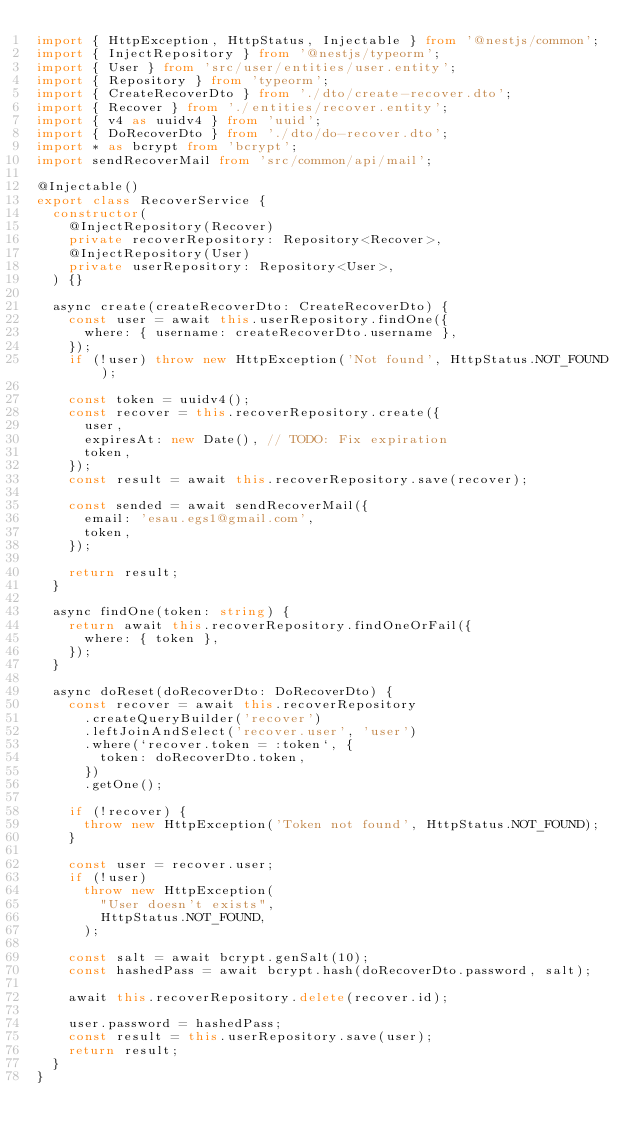Convert code to text. <code><loc_0><loc_0><loc_500><loc_500><_TypeScript_>import { HttpException, HttpStatus, Injectable } from '@nestjs/common';
import { InjectRepository } from '@nestjs/typeorm';
import { User } from 'src/user/entities/user.entity';
import { Repository } from 'typeorm';
import { CreateRecoverDto } from './dto/create-recover.dto';
import { Recover } from './entities/recover.entity';
import { v4 as uuidv4 } from 'uuid';
import { DoRecoverDto } from './dto/do-recover.dto';
import * as bcrypt from 'bcrypt';
import sendRecoverMail from 'src/common/api/mail';

@Injectable()
export class RecoverService {
	constructor(
		@InjectRepository(Recover)
		private recoverRepository: Repository<Recover>,
		@InjectRepository(User)
		private userRepository: Repository<User>,
	) {}

	async create(createRecoverDto: CreateRecoverDto) {
		const user = await this.userRepository.findOne({
			where: { username: createRecoverDto.username },
		});
		if (!user) throw new HttpException('Not found', HttpStatus.NOT_FOUND);

		const token = uuidv4();
		const recover = this.recoverRepository.create({
			user,
			expiresAt: new Date(), // TODO: Fix expiration
			token,
		});
		const result = await this.recoverRepository.save(recover);

		const sended = await sendRecoverMail({
			email: 'esau.egs1@gmail.com',
			token,
		});

		return result;
	}

	async findOne(token: string) {
		return await this.recoverRepository.findOneOrFail({
			where: { token },
		});
	}

	async doReset(doRecoverDto: DoRecoverDto) {
		const recover = await this.recoverRepository
			.createQueryBuilder('recover')
			.leftJoinAndSelect('recover.user', 'user')
			.where(`recover.token = :token`, {
				token: doRecoverDto.token,
			})
			.getOne();

		if (!recover) {
			throw new HttpException('Token not found', HttpStatus.NOT_FOUND);
		}

		const user = recover.user;
		if (!user)
			throw new HttpException(
				"User doesn't exists",
				HttpStatus.NOT_FOUND,
			);

		const salt = await bcrypt.genSalt(10);
		const hashedPass = await bcrypt.hash(doRecoverDto.password, salt);

		await this.recoverRepository.delete(recover.id);

		user.password = hashedPass;
		const result = this.userRepository.save(user);
		return result;
	}
}
</code> 